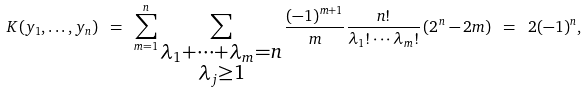<formula> <loc_0><loc_0><loc_500><loc_500>K ( y _ { 1 } , \dots , y _ { n } ) \ = \ \sum _ { m = 1 } ^ { n } \sum _ { \substack { \lambda _ { 1 } + \cdots + \lambda _ { m } = n \\ \lambda _ { j } \geq 1 } } \frac { ( - 1 ) ^ { m + 1 } } { m } \frac { n ! } { \lambda _ { 1 } ! \cdots \lambda _ { m } ! } \left ( 2 ^ { n } - 2 m \right ) \ = \ 2 ( - 1 ) ^ { n } ,</formula> 